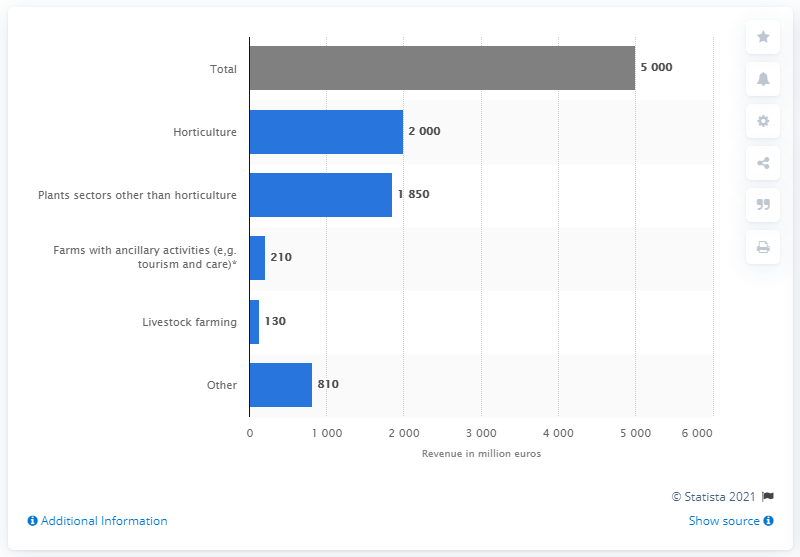Outline some significant characteristics in this image. Horticulture is expected to lose two billion euros in revenue in 2020 due to industry expectations. 